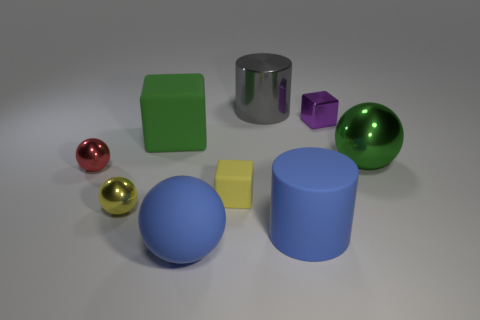Subtract all red shiny spheres. How many spheres are left? 3 Subtract all green cubes. How many cubes are left? 2 Subtract 1 cylinders. How many cylinders are left? 1 Subtract all gray cylinders. Subtract all brown cubes. How many cylinders are left? 1 Subtract all brown cubes. How many purple spheres are left? 0 Subtract all small cyan rubber cubes. Subtract all tiny things. How many objects are left? 5 Add 3 yellow rubber cubes. How many yellow rubber cubes are left? 4 Add 2 small gray blocks. How many small gray blocks exist? 2 Add 1 tiny purple blocks. How many objects exist? 10 Subtract 0 yellow cylinders. How many objects are left? 9 